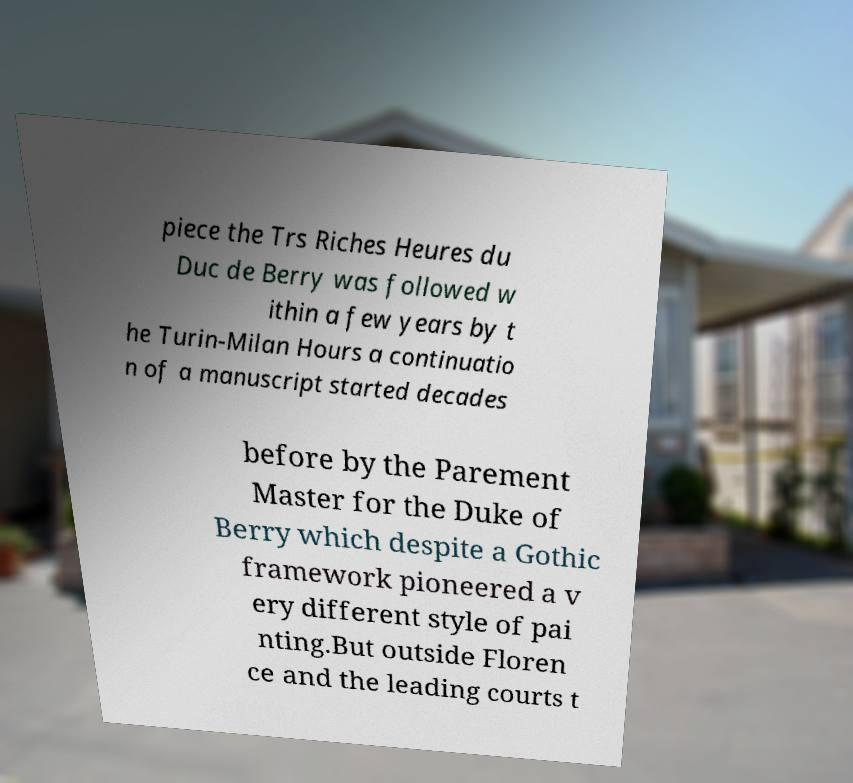Can you read and provide the text displayed in the image?This photo seems to have some interesting text. Can you extract and type it out for me? piece the Trs Riches Heures du Duc de Berry was followed w ithin a few years by t he Turin-Milan Hours a continuatio n of a manuscript started decades before by the Parement Master for the Duke of Berry which despite a Gothic framework pioneered a v ery different style of pai nting.But outside Floren ce and the leading courts t 